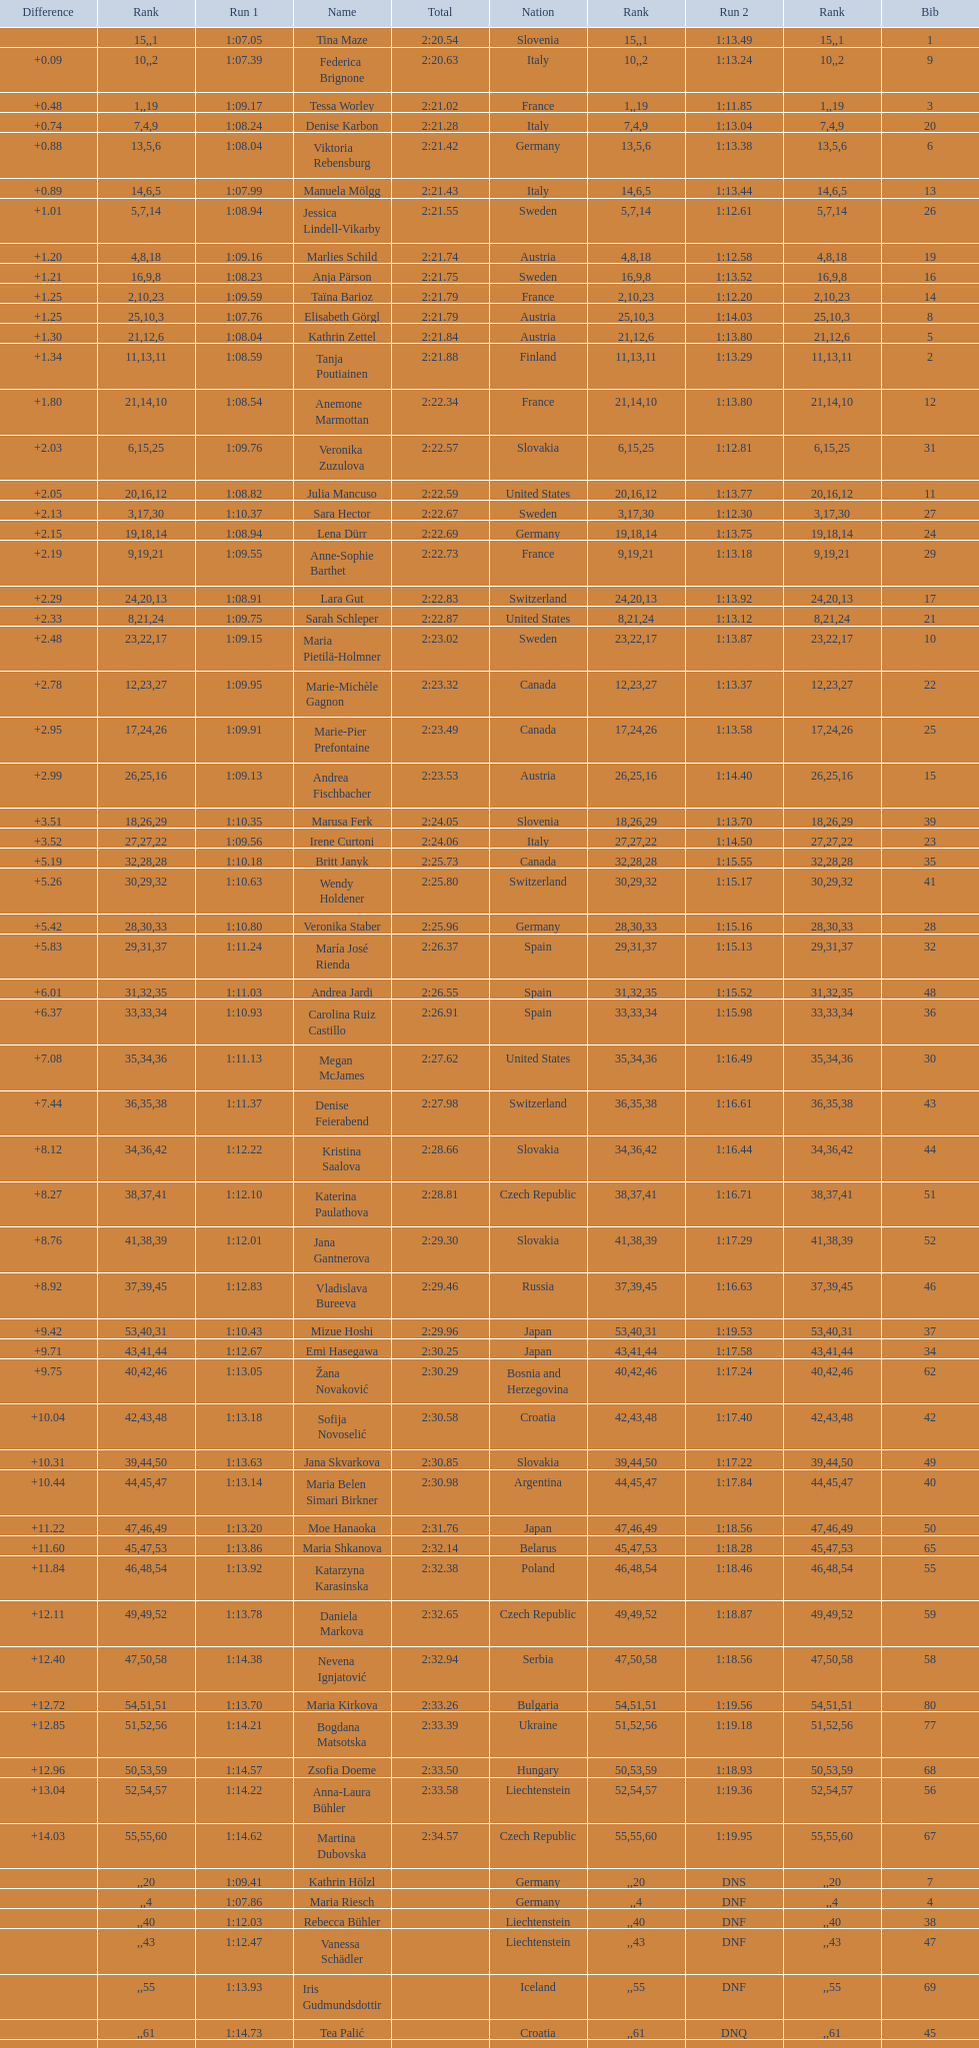How many athletes had the same rank for both run 1 and run 2? 1. 